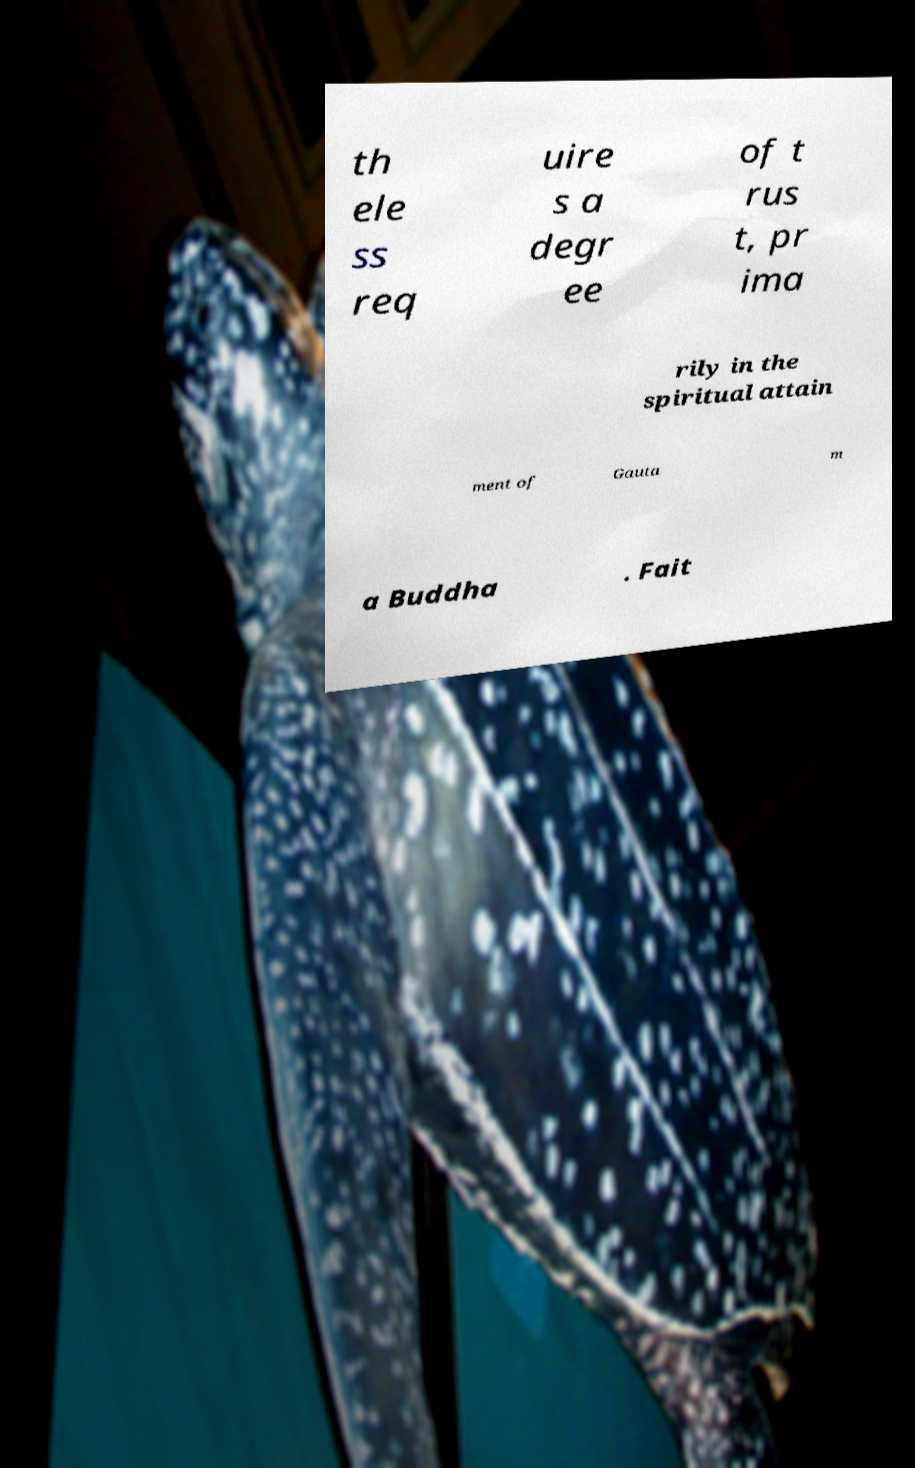What messages or text are displayed in this image? I need them in a readable, typed format. th ele ss req uire s a degr ee of t rus t, pr ima rily in the spiritual attain ment of Gauta m a Buddha . Fait 